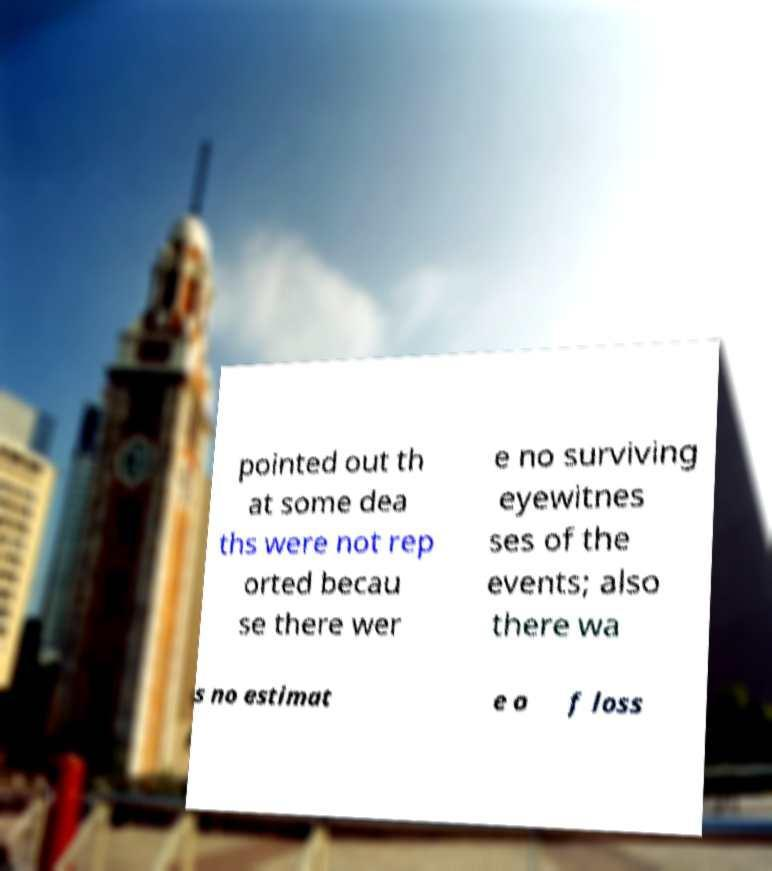Could you extract and type out the text from this image? pointed out th at some dea ths were not rep orted becau se there wer e no surviving eyewitnes ses of the events; also there wa s no estimat e o f loss 